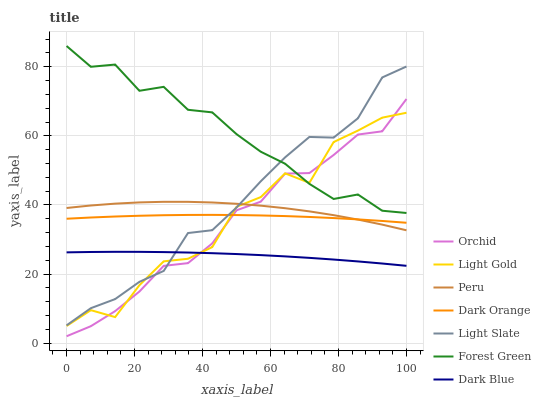Does Dark Blue have the minimum area under the curve?
Answer yes or no. Yes. Does Forest Green have the maximum area under the curve?
Answer yes or no. Yes. Does Light Slate have the minimum area under the curve?
Answer yes or no. No. Does Light Slate have the maximum area under the curve?
Answer yes or no. No. Is Dark Blue the smoothest?
Answer yes or no. Yes. Is Light Gold the roughest?
Answer yes or no. Yes. Is Light Slate the smoothest?
Answer yes or no. No. Is Light Slate the roughest?
Answer yes or no. No. Does Orchid have the lowest value?
Answer yes or no. Yes. Does Light Slate have the lowest value?
Answer yes or no. No. Does Forest Green have the highest value?
Answer yes or no. Yes. Does Light Slate have the highest value?
Answer yes or no. No. Is Dark Orange less than Forest Green?
Answer yes or no. Yes. Is Dark Orange greater than Dark Blue?
Answer yes or no. Yes. Does Peru intersect Light Slate?
Answer yes or no. Yes. Is Peru less than Light Slate?
Answer yes or no. No. Is Peru greater than Light Slate?
Answer yes or no. No. Does Dark Orange intersect Forest Green?
Answer yes or no. No. 